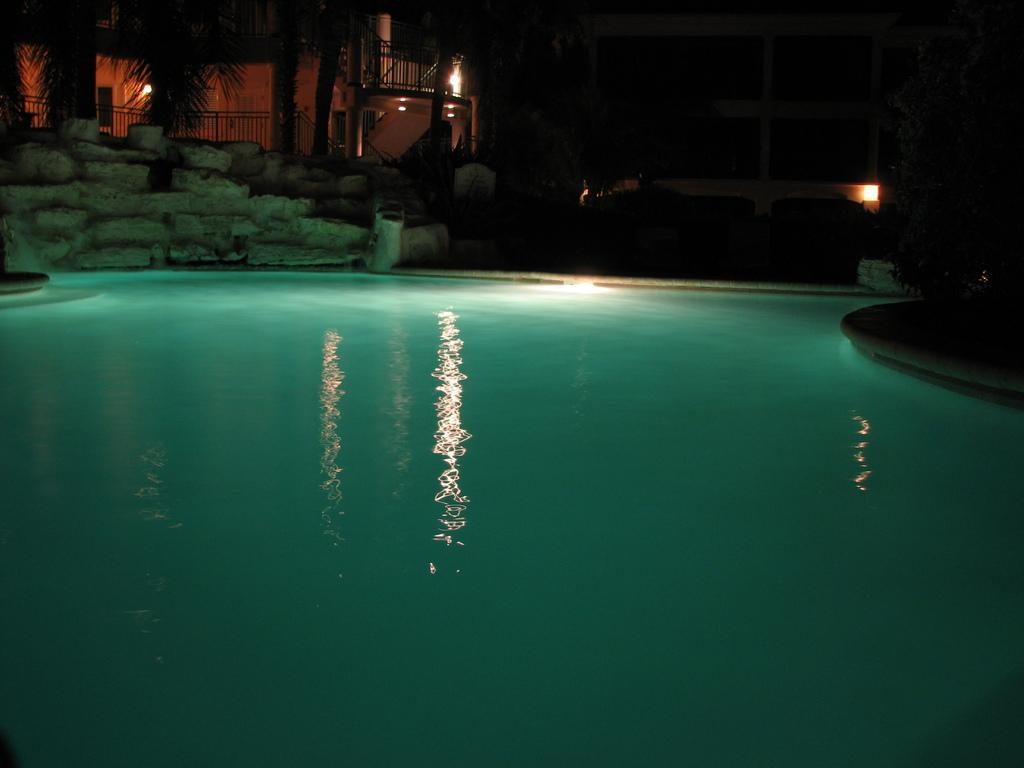What type of structures can be seen in the image? There are buildings in the image. Where are the buildings located in relation to the other elements in the image? The buildings are at the top of the image. What is the main body of water in the image? There is water in the image, and it appears to be a swimming pool. Where is the water located in the image? The water is in the middle of the image. What type of vegetation is present in the image? There are trees in the image. Where are the trees located in relation to the other elements in the image? The trees are at the top of the image. How many wishes can be granted by the eyes of the person swimming in the pool? There is no person swimming in the pool, and therefore no eyes or wishes to consider. Can you describe the wing of the bird flying over the trees in the image? There is no bird or wing present in the image; it depicts buildings, water, and trees. 